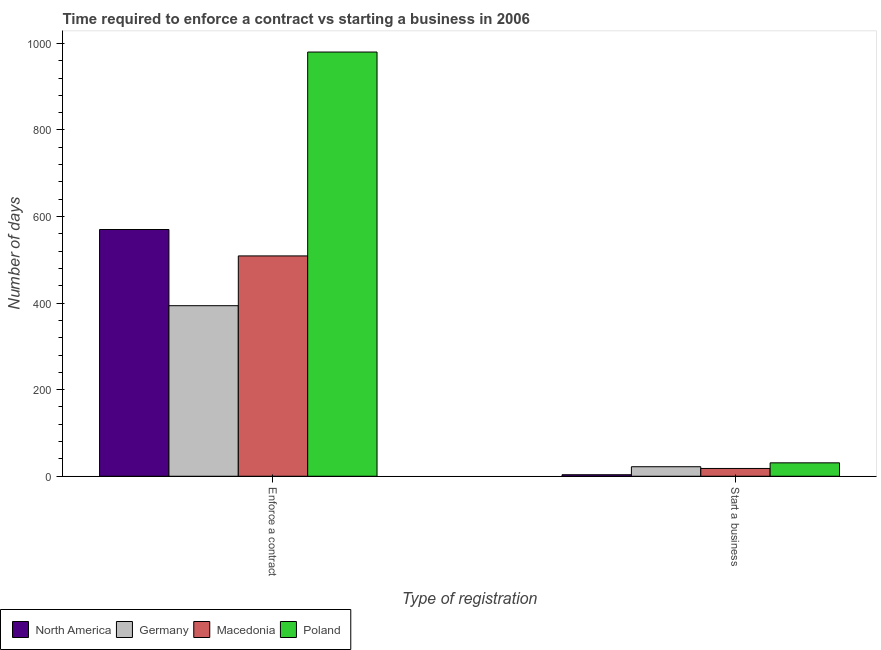How many different coloured bars are there?
Your response must be concise. 4. What is the label of the 2nd group of bars from the left?
Offer a terse response. Start a business. What is the number of days to start a business in Poland?
Your answer should be compact. 31. Across all countries, what is the maximum number of days to enforece a contract?
Give a very brief answer. 980. Across all countries, what is the minimum number of days to enforece a contract?
Ensure brevity in your answer.  394. In which country was the number of days to start a business minimum?
Your answer should be very brief. North America. What is the total number of days to enforece a contract in the graph?
Give a very brief answer. 2453. What is the difference between the number of days to start a business in North America and that in Germany?
Keep it short and to the point. -18.5. What is the difference between the number of days to enforece a contract in North America and the number of days to start a business in Macedonia?
Your answer should be compact. 552. What is the average number of days to start a business per country?
Your answer should be compact. 18.62. What is the difference between the number of days to start a business and number of days to enforece a contract in Poland?
Offer a very short reply. -949. In how many countries, is the number of days to start a business greater than 80 days?
Ensure brevity in your answer.  0. What is the ratio of the number of days to enforece a contract in Germany to that in North America?
Give a very brief answer. 0.69. In how many countries, is the number of days to enforece a contract greater than the average number of days to enforece a contract taken over all countries?
Make the answer very short. 1. Are all the bars in the graph horizontal?
Provide a succinct answer. No. Does the graph contain any zero values?
Give a very brief answer. No. How are the legend labels stacked?
Offer a terse response. Horizontal. What is the title of the graph?
Your answer should be very brief. Time required to enforce a contract vs starting a business in 2006. Does "Lao PDR" appear as one of the legend labels in the graph?
Give a very brief answer. No. What is the label or title of the X-axis?
Provide a succinct answer. Type of registration. What is the label or title of the Y-axis?
Provide a short and direct response. Number of days. What is the Number of days of North America in Enforce a contract?
Your response must be concise. 570. What is the Number of days in Germany in Enforce a contract?
Provide a short and direct response. 394. What is the Number of days of Macedonia in Enforce a contract?
Your answer should be compact. 509. What is the Number of days in Poland in Enforce a contract?
Ensure brevity in your answer.  980. What is the Number of days in North America in Start a business?
Offer a terse response. 3.5. What is the Number of days in Macedonia in Start a business?
Provide a succinct answer. 18. Across all Type of registration, what is the maximum Number of days of North America?
Make the answer very short. 570. Across all Type of registration, what is the maximum Number of days in Germany?
Make the answer very short. 394. Across all Type of registration, what is the maximum Number of days in Macedonia?
Provide a short and direct response. 509. Across all Type of registration, what is the maximum Number of days in Poland?
Offer a terse response. 980. Across all Type of registration, what is the minimum Number of days in Macedonia?
Give a very brief answer. 18. What is the total Number of days of North America in the graph?
Your answer should be very brief. 573.5. What is the total Number of days of Germany in the graph?
Offer a very short reply. 416. What is the total Number of days of Macedonia in the graph?
Keep it short and to the point. 527. What is the total Number of days in Poland in the graph?
Offer a very short reply. 1011. What is the difference between the Number of days in North America in Enforce a contract and that in Start a business?
Offer a very short reply. 566.5. What is the difference between the Number of days of Germany in Enforce a contract and that in Start a business?
Make the answer very short. 372. What is the difference between the Number of days of Macedonia in Enforce a contract and that in Start a business?
Offer a terse response. 491. What is the difference between the Number of days in Poland in Enforce a contract and that in Start a business?
Give a very brief answer. 949. What is the difference between the Number of days in North America in Enforce a contract and the Number of days in Germany in Start a business?
Your answer should be compact. 548. What is the difference between the Number of days in North America in Enforce a contract and the Number of days in Macedonia in Start a business?
Your answer should be compact. 552. What is the difference between the Number of days of North America in Enforce a contract and the Number of days of Poland in Start a business?
Offer a terse response. 539. What is the difference between the Number of days in Germany in Enforce a contract and the Number of days in Macedonia in Start a business?
Give a very brief answer. 376. What is the difference between the Number of days of Germany in Enforce a contract and the Number of days of Poland in Start a business?
Keep it short and to the point. 363. What is the difference between the Number of days of Macedonia in Enforce a contract and the Number of days of Poland in Start a business?
Ensure brevity in your answer.  478. What is the average Number of days of North America per Type of registration?
Provide a succinct answer. 286.75. What is the average Number of days in Germany per Type of registration?
Make the answer very short. 208. What is the average Number of days of Macedonia per Type of registration?
Offer a terse response. 263.5. What is the average Number of days of Poland per Type of registration?
Ensure brevity in your answer.  505.5. What is the difference between the Number of days in North America and Number of days in Germany in Enforce a contract?
Give a very brief answer. 176. What is the difference between the Number of days of North America and Number of days of Macedonia in Enforce a contract?
Make the answer very short. 61. What is the difference between the Number of days in North America and Number of days in Poland in Enforce a contract?
Your response must be concise. -410. What is the difference between the Number of days of Germany and Number of days of Macedonia in Enforce a contract?
Your answer should be compact. -115. What is the difference between the Number of days of Germany and Number of days of Poland in Enforce a contract?
Your response must be concise. -586. What is the difference between the Number of days of Macedonia and Number of days of Poland in Enforce a contract?
Your answer should be compact. -471. What is the difference between the Number of days of North America and Number of days of Germany in Start a business?
Your answer should be compact. -18.5. What is the difference between the Number of days in North America and Number of days in Poland in Start a business?
Offer a very short reply. -27.5. What is the difference between the Number of days of Germany and Number of days of Macedonia in Start a business?
Give a very brief answer. 4. What is the difference between the Number of days in Germany and Number of days in Poland in Start a business?
Offer a terse response. -9. What is the difference between the Number of days of Macedonia and Number of days of Poland in Start a business?
Provide a short and direct response. -13. What is the ratio of the Number of days in North America in Enforce a contract to that in Start a business?
Give a very brief answer. 162.86. What is the ratio of the Number of days in Germany in Enforce a contract to that in Start a business?
Your answer should be very brief. 17.91. What is the ratio of the Number of days of Macedonia in Enforce a contract to that in Start a business?
Your answer should be very brief. 28.28. What is the ratio of the Number of days of Poland in Enforce a contract to that in Start a business?
Make the answer very short. 31.61. What is the difference between the highest and the second highest Number of days in North America?
Offer a terse response. 566.5. What is the difference between the highest and the second highest Number of days of Germany?
Your answer should be compact. 372. What is the difference between the highest and the second highest Number of days of Macedonia?
Provide a succinct answer. 491. What is the difference between the highest and the second highest Number of days of Poland?
Give a very brief answer. 949. What is the difference between the highest and the lowest Number of days of North America?
Your answer should be compact. 566.5. What is the difference between the highest and the lowest Number of days in Germany?
Provide a short and direct response. 372. What is the difference between the highest and the lowest Number of days in Macedonia?
Provide a short and direct response. 491. What is the difference between the highest and the lowest Number of days of Poland?
Your response must be concise. 949. 